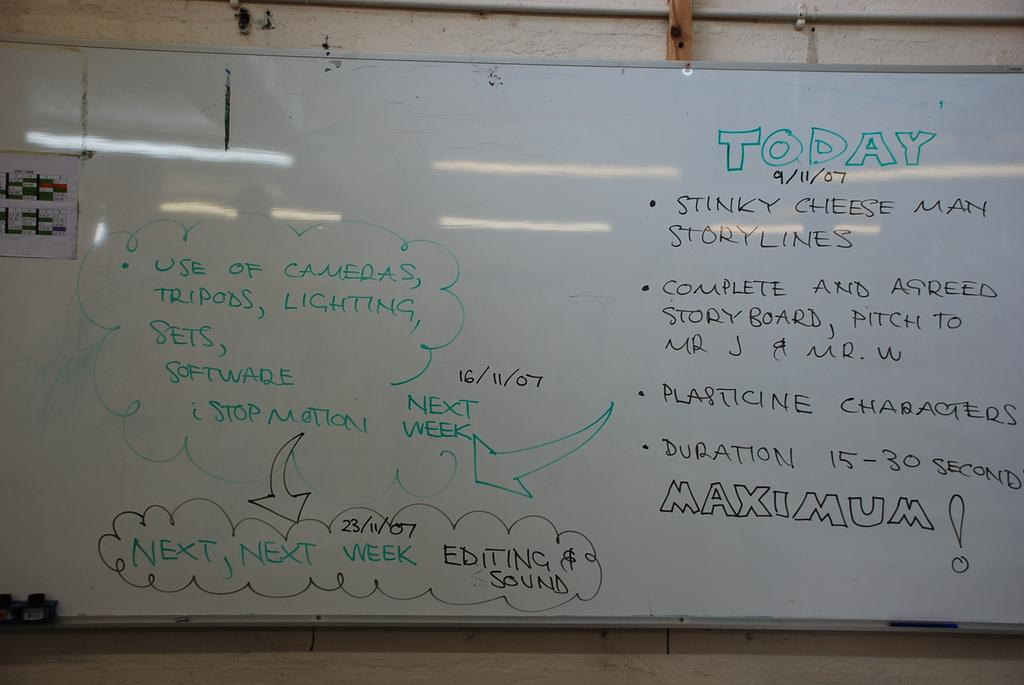<image>
Provide a brief description of the given image. Someone has written the word today at the top of this whiteboard. 